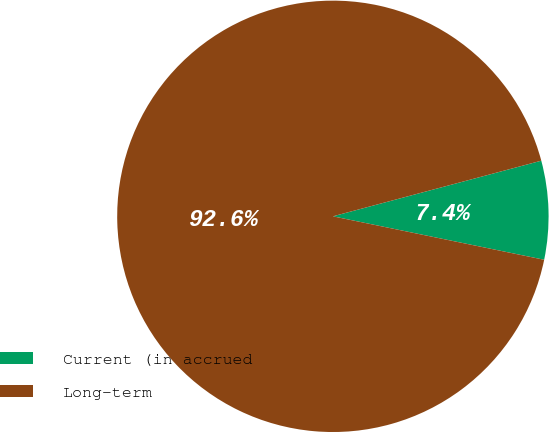<chart> <loc_0><loc_0><loc_500><loc_500><pie_chart><fcel>Current (in accrued<fcel>Long-term<nl><fcel>7.38%<fcel>92.62%<nl></chart> 